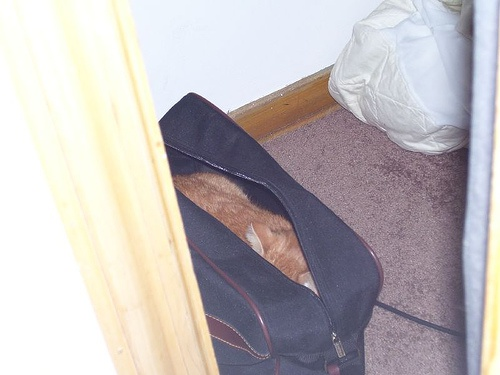Describe the objects in this image and their specific colors. I can see a cat in white, gray, darkgray, salmon, and tan tones in this image. 